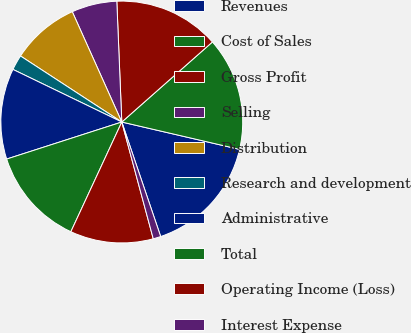Convert chart to OTSL. <chart><loc_0><loc_0><loc_500><loc_500><pie_chart><fcel>Revenues<fcel>Cost of Sales<fcel>Gross Profit<fcel>Selling<fcel>Distribution<fcel>Research and development<fcel>Administrative<fcel>Total<fcel>Operating Income (Loss)<fcel>Interest Expense<nl><fcel>16.16%<fcel>15.15%<fcel>14.14%<fcel>6.06%<fcel>9.09%<fcel>2.03%<fcel>12.12%<fcel>13.13%<fcel>11.11%<fcel>1.02%<nl></chart> 